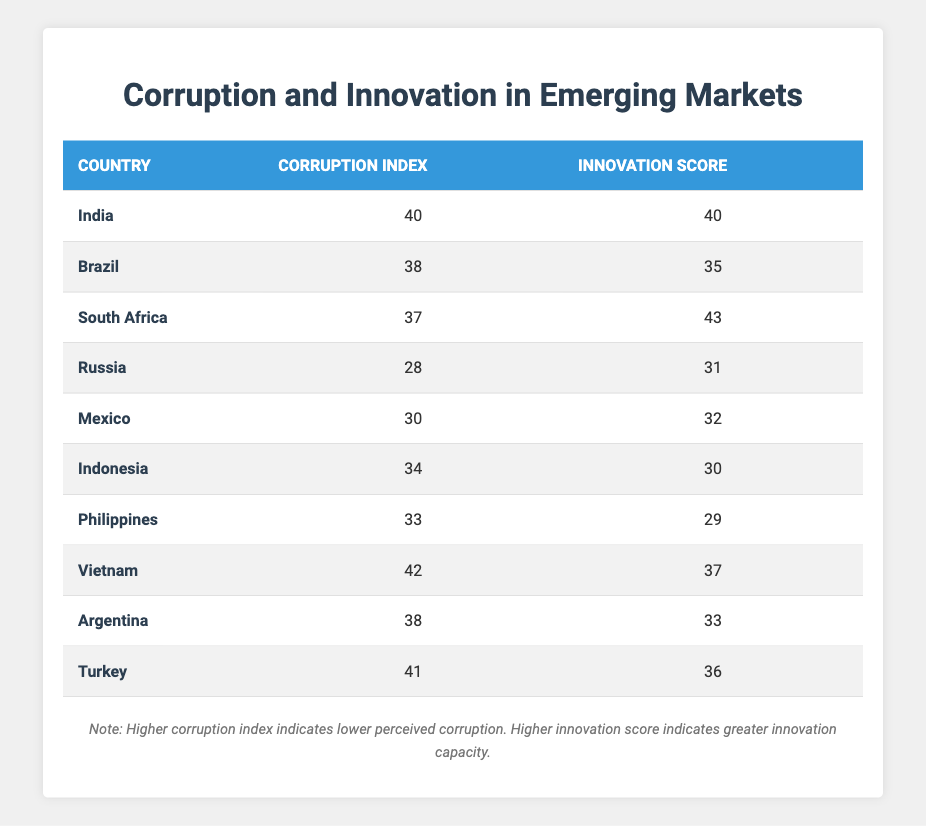What is the corruption index of Brazil? Brazil's corruption index is directly listed in the table under the "Corruption Index" column. It shows a value of 38.
Answer: 38 Which country has the highest innovation score? To find the country with the highest innovation score, we compare the values in the "Innovation Score" column. South Africa has the highest score of 43.
Answer: South Africa What is the average corruption index of the countries listed in the table? To calculate the average corruption index, we sum all the corruption index values: 40 + 38 + 37 + 28 + 30 + 34 + 33 + 42 + 38 + 41 =  389. There are 10 countries, so the average is 389 / 10 = 38.9.
Answer: 38.9 Is the innovation score of Indonesia higher than that of Brazil? Indonesia's innovation score is 30, while Brazil's innovation score is 35, indicating that Indonesia's score is lower. Thus, the statement is false.
Answer: No Which country has the lowest corruption index and what is its innovation score? In the table, Russia has the lowest corruption index at 28. By locating it in the same row, we find that its innovation score is 31.
Answer: Russia, 31 If we group countries by their innovation scores, how many have scores below 35? By checking the innovation scores listed in the table, we identify the countries with scores below 35: Brazil (35), Indonesia (30), Philippines (29), and Mexico (32). This gives us a total of 4 countries.
Answer: 4 Is there a positive correlation between corruption index and innovation score based on the provided data? A positive correlation would mean that as the corruption index increases, the innovation score also increases. In the table, while some countries have higher corruption indexes and lower innovation scores (e.g., Brazil), others have the opposite (South Africa). This mixed pattern suggests a lack of clear positive correlation.
Answer: No What is the difference between the highest and lowest innovation scores? The highest innovation score is 43 (South Africa), and the lowest is 29 (Philippines). The difference is calculated as 43 - 29 = 14.
Answer: 14 Which country has a corruption index of 41, and what is its innovation score? By reviewing the corruption index column, Turkey is the country listed with a corruption index of 41. We then check the corresponding row to see that its innovation score is 36.
Answer: Turkey, 36 